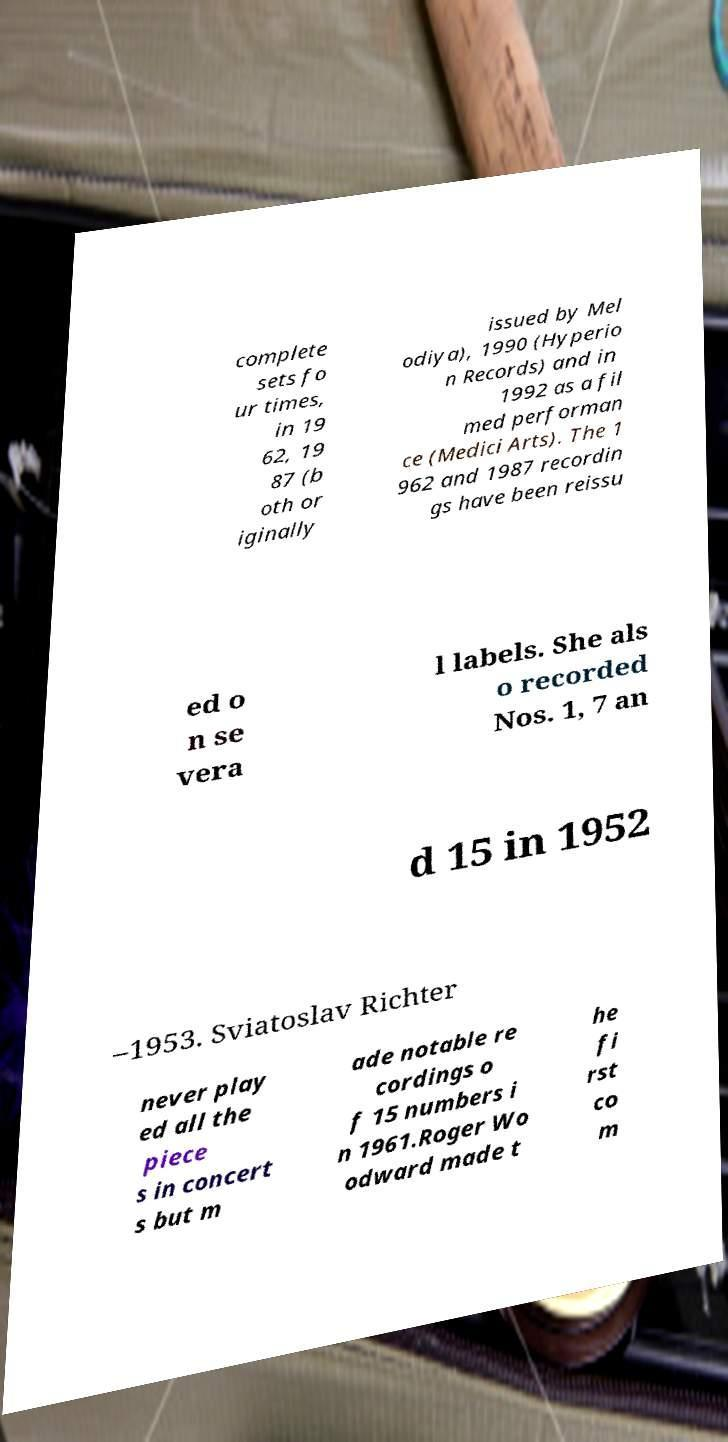Can you accurately transcribe the text from the provided image for me? complete sets fo ur times, in 19 62, 19 87 (b oth or iginally issued by Mel odiya), 1990 (Hyperio n Records) and in 1992 as a fil med performan ce (Medici Arts). The 1 962 and 1987 recordin gs have been reissu ed o n se vera l labels. She als o recorded Nos. 1, 7 an d 15 in 1952 –1953. Sviatoslav Richter never play ed all the piece s in concert s but m ade notable re cordings o f 15 numbers i n 1961.Roger Wo odward made t he fi rst co m 